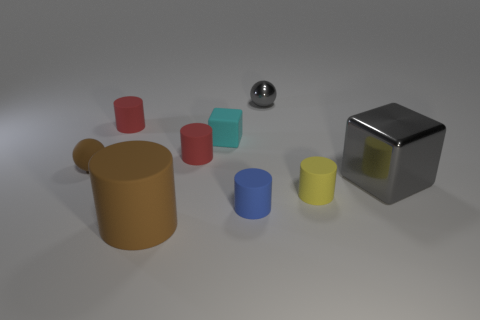Subtract all blue cylinders. How many cylinders are left? 4 Subtract all blue rubber cylinders. How many cylinders are left? 4 Add 1 big gray metallic blocks. How many objects exist? 10 Subtract all gray cylinders. Subtract all green cubes. How many cylinders are left? 5 Subtract all blocks. How many objects are left? 7 Add 3 big rubber things. How many big rubber things are left? 4 Add 6 red matte objects. How many red matte objects exist? 8 Subtract 0 purple cylinders. How many objects are left? 9 Subtract all big yellow shiny cylinders. Subtract all small rubber things. How many objects are left? 3 